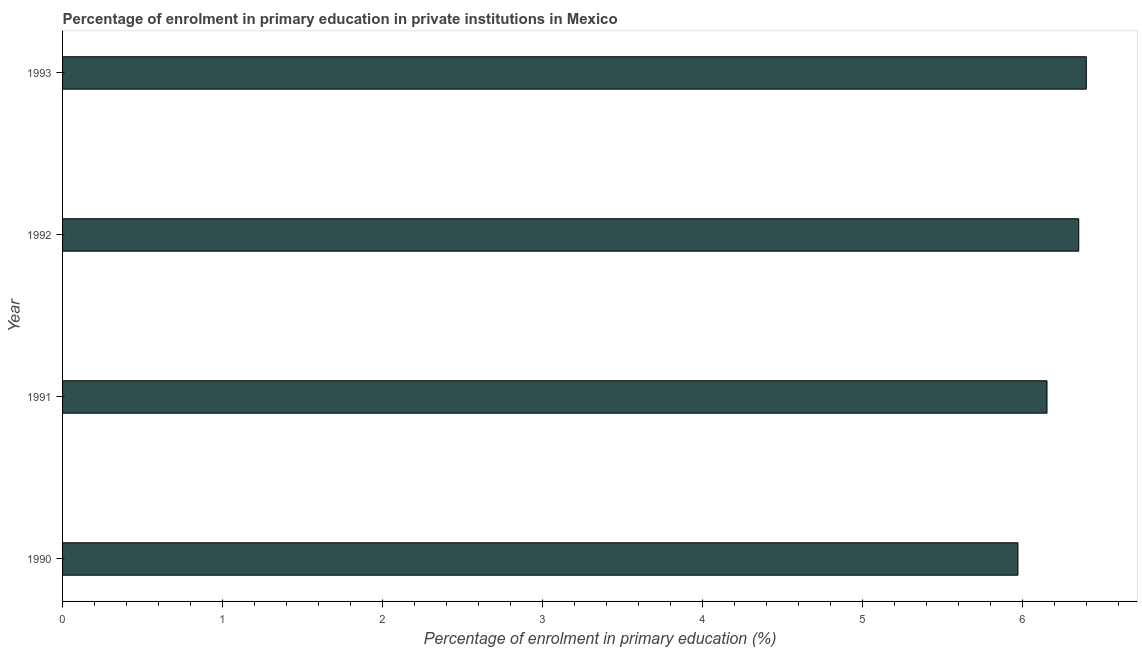What is the title of the graph?
Offer a terse response. Percentage of enrolment in primary education in private institutions in Mexico. What is the label or title of the X-axis?
Your answer should be very brief. Percentage of enrolment in primary education (%). What is the enrolment percentage in primary education in 1992?
Offer a terse response. 6.35. Across all years, what is the maximum enrolment percentage in primary education?
Your answer should be compact. 6.4. Across all years, what is the minimum enrolment percentage in primary education?
Your response must be concise. 5.97. What is the sum of the enrolment percentage in primary education?
Ensure brevity in your answer.  24.86. What is the difference between the enrolment percentage in primary education in 1990 and 1993?
Keep it short and to the point. -0.43. What is the average enrolment percentage in primary education per year?
Offer a terse response. 6.22. What is the median enrolment percentage in primary education?
Provide a succinct answer. 6.25. In how many years, is the enrolment percentage in primary education greater than 6 %?
Your response must be concise. 3. Do a majority of the years between 1991 and 1993 (inclusive) have enrolment percentage in primary education greater than 1.6 %?
Provide a succinct answer. Yes. What is the ratio of the enrolment percentage in primary education in 1990 to that in 1993?
Ensure brevity in your answer.  0.93. What is the difference between the highest and the second highest enrolment percentage in primary education?
Your response must be concise. 0.05. What is the difference between the highest and the lowest enrolment percentage in primary education?
Keep it short and to the point. 0.43. In how many years, is the enrolment percentage in primary education greater than the average enrolment percentage in primary education taken over all years?
Offer a terse response. 2. How many bars are there?
Keep it short and to the point. 4. How many years are there in the graph?
Your answer should be very brief. 4. What is the difference between two consecutive major ticks on the X-axis?
Offer a very short reply. 1. What is the Percentage of enrolment in primary education (%) in 1990?
Keep it short and to the point. 5.97. What is the Percentage of enrolment in primary education (%) in 1991?
Your answer should be very brief. 6.15. What is the Percentage of enrolment in primary education (%) in 1992?
Offer a terse response. 6.35. What is the Percentage of enrolment in primary education (%) of 1993?
Provide a short and direct response. 6.4. What is the difference between the Percentage of enrolment in primary education (%) in 1990 and 1991?
Provide a short and direct response. -0.18. What is the difference between the Percentage of enrolment in primary education (%) in 1990 and 1992?
Your answer should be compact. -0.38. What is the difference between the Percentage of enrolment in primary education (%) in 1990 and 1993?
Provide a succinct answer. -0.43. What is the difference between the Percentage of enrolment in primary education (%) in 1991 and 1992?
Offer a very short reply. -0.2. What is the difference between the Percentage of enrolment in primary education (%) in 1991 and 1993?
Provide a short and direct response. -0.25. What is the difference between the Percentage of enrolment in primary education (%) in 1992 and 1993?
Provide a succinct answer. -0.05. What is the ratio of the Percentage of enrolment in primary education (%) in 1990 to that in 1991?
Provide a short and direct response. 0.97. What is the ratio of the Percentage of enrolment in primary education (%) in 1990 to that in 1992?
Give a very brief answer. 0.94. What is the ratio of the Percentage of enrolment in primary education (%) in 1990 to that in 1993?
Your answer should be compact. 0.93. What is the ratio of the Percentage of enrolment in primary education (%) in 1991 to that in 1992?
Make the answer very short. 0.97. 